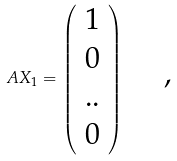Convert formula to latex. <formula><loc_0><loc_0><loc_500><loc_500>A X _ { 1 } = \left ( \begin{array} { c } 1 \\ 0 \\ . . \\ 0 \end{array} \right ) \text { \quad ,}</formula> 